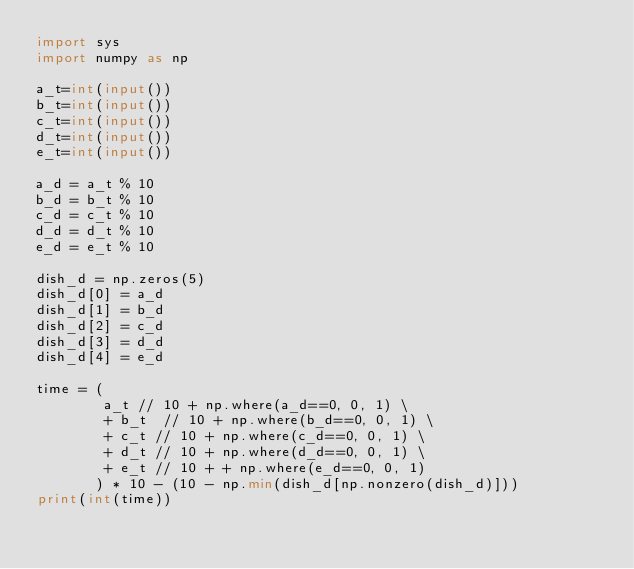Convert code to text. <code><loc_0><loc_0><loc_500><loc_500><_Python_>import sys
import numpy as np

a_t=int(input())
b_t=int(input())
c_t=int(input())
d_t=int(input())
e_t=int(input())

a_d = a_t % 10
b_d = b_t % 10
c_d = c_t % 10 
d_d = d_t % 10
e_d = e_t % 10

dish_d = np.zeros(5)
dish_d[0] = a_d
dish_d[1] = b_d
dish_d[2] = c_d
dish_d[3] = d_d
dish_d[4] = e_d

time = (
        a_t // 10 + np.where(a_d==0, 0, 1) \
        + b_t  // 10 + np.where(b_d==0, 0, 1) \
        + c_t // 10 + np.where(c_d==0, 0, 1) \
        + d_t // 10 + np.where(d_d==0, 0, 1) \
        + e_t // 10 + + np.where(e_d==0, 0, 1)
       ) * 10 - (10 - np.min(dish_d[np.nonzero(dish_d)]))
print(int(time))</code> 